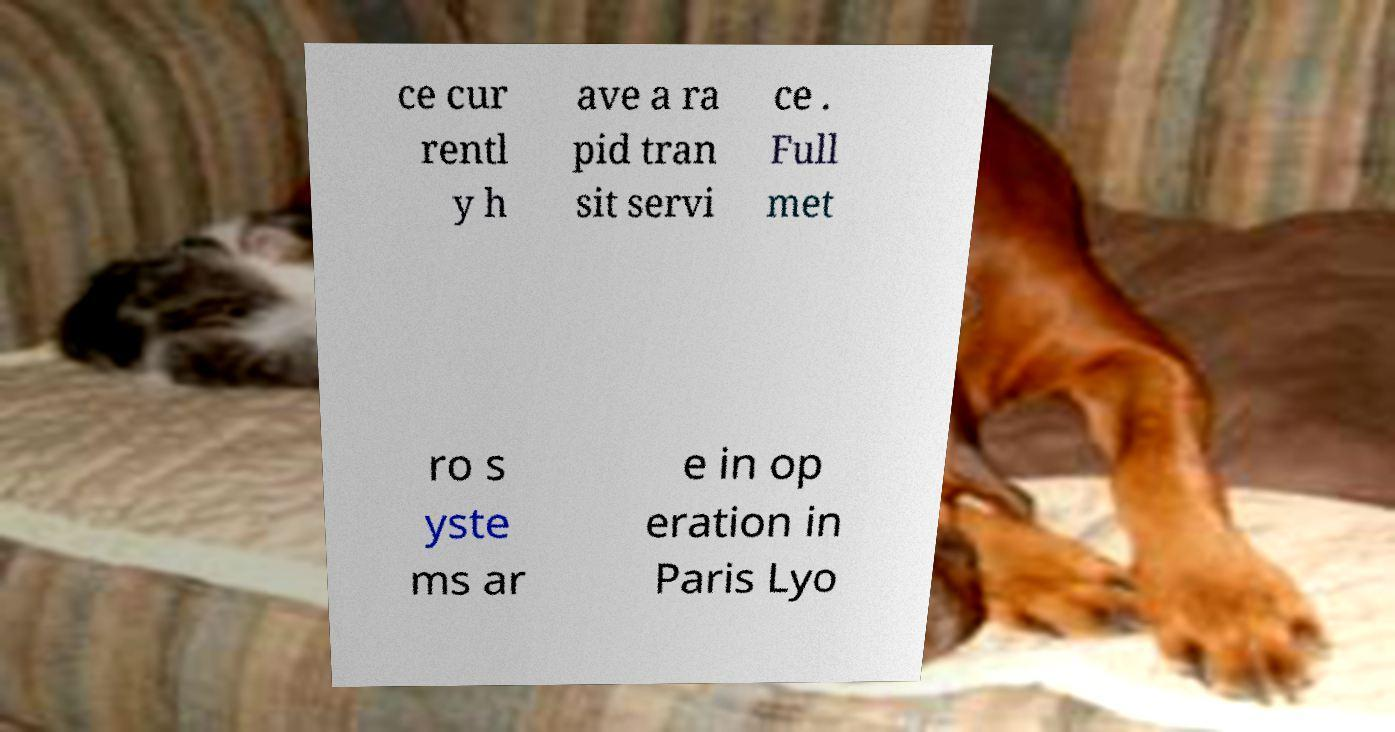Please read and relay the text visible in this image. What does it say? ce cur rentl y h ave a ra pid tran sit servi ce . Full met ro s yste ms ar e in op eration in Paris Lyo 